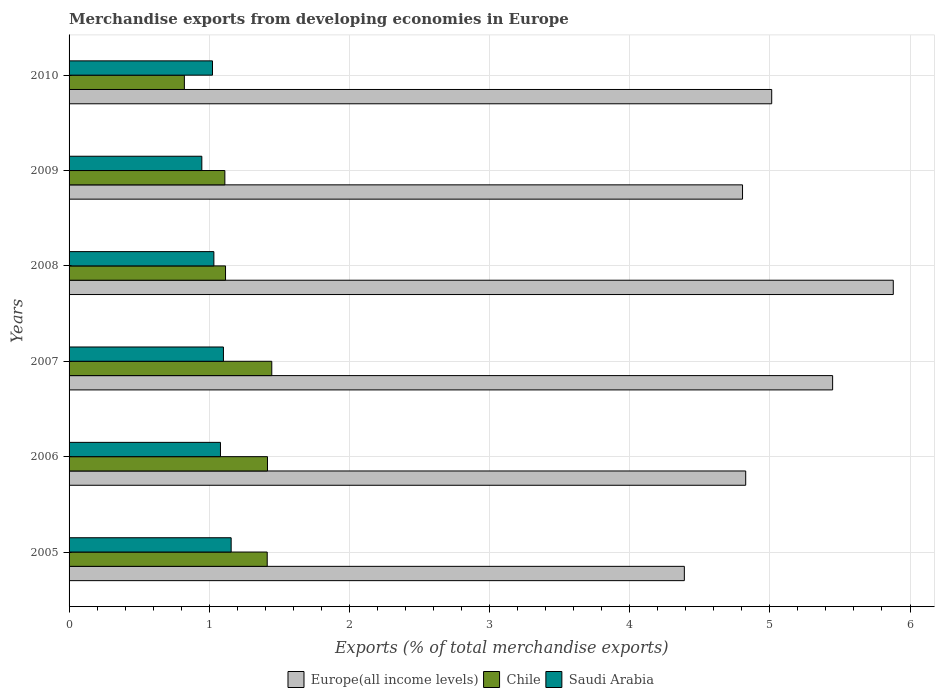Are the number of bars per tick equal to the number of legend labels?
Give a very brief answer. Yes. Are the number of bars on each tick of the Y-axis equal?
Ensure brevity in your answer.  Yes. How many bars are there on the 3rd tick from the top?
Give a very brief answer. 3. In how many cases, is the number of bars for a given year not equal to the number of legend labels?
Your response must be concise. 0. What is the percentage of total merchandise exports in Chile in 2007?
Make the answer very short. 1.45. Across all years, what is the maximum percentage of total merchandise exports in Chile?
Ensure brevity in your answer.  1.45. Across all years, what is the minimum percentage of total merchandise exports in Europe(all income levels)?
Your response must be concise. 4.39. In which year was the percentage of total merchandise exports in Europe(all income levels) maximum?
Offer a very short reply. 2008. In which year was the percentage of total merchandise exports in Saudi Arabia minimum?
Your response must be concise. 2009. What is the total percentage of total merchandise exports in Saudi Arabia in the graph?
Your answer should be compact. 6.34. What is the difference between the percentage of total merchandise exports in Saudi Arabia in 2006 and that in 2008?
Ensure brevity in your answer.  0.05. What is the difference between the percentage of total merchandise exports in Europe(all income levels) in 2009 and the percentage of total merchandise exports in Saudi Arabia in 2008?
Provide a succinct answer. 3.77. What is the average percentage of total merchandise exports in Europe(all income levels) per year?
Your response must be concise. 5.06. In the year 2010, what is the difference between the percentage of total merchandise exports in Europe(all income levels) and percentage of total merchandise exports in Saudi Arabia?
Provide a succinct answer. 3.99. What is the ratio of the percentage of total merchandise exports in Chile in 2005 to that in 2010?
Offer a very short reply. 1.72. Is the percentage of total merchandise exports in Chile in 2007 less than that in 2008?
Your answer should be compact. No. Is the difference between the percentage of total merchandise exports in Europe(all income levels) in 2005 and 2010 greater than the difference between the percentage of total merchandise exports in Saudi Arabia in 2005 and 2010?
Provide a succinct answer. No. What is the difference between the highest and the second highest percentage of total merchandise exports in Europe(all income levels)?
Your answer should be very brief. 0.43. What is the difference between the highest and the lowest percentage of total merchandise exports in Saudi Arabia?
Offer a terse response. 0.21. In how many years, is the percentage of total merchandise exports in Europe(all income levels) greater than the average percentage of total merchandise exports in Europe(all income levels) taken over all years?
Keep it short and to the point. 2. What does the 3rd bar from the top in 2007 represents?
Provide a short and direct response. Europe(all income levels). What does the 3rd bar from the bottom in 2008 represents?
Your answer should be very brief. Saudi Arabia. Is it the case that in every year, the sum of the percentage of total merchandise exports in Europe(all income levels) and percentage of total merchandise exports in Chile is greater than the percentage of total merchandise exports in Saudi Arabia?
Offer a very short reply. Yes. How many bars are there?
Your answer should be compact. 18. Are all the bars in the graph horizontal?
Provide a succinct answer. Yes. How many years are there in the graph?
Give a very brief answer. 6. What is the difference between two consecutive major ticks on the X-axis?
Your answer should be compact. 1. Are the values on the major ticks of X-axis written in scientific E-notation?
Your answer should be very brief. No. How many legend labels are there?
Make the answer very short. 3. How are the legend labels stacked?
Your answer should be very brief. Horizontal. What is the title of the graph?
Offer a terse response. Merchandise exports from developing economies in Europe. Does "Mauritius" appear as one of the legend labels in the graph?
Your answer should be compact. No. What is the label or title of the X-axis?
Your answer should be very brief. Exports (% of total merchandise exports). What is the label or title of the Y-axis?
Your answer should be very brief. Years. What is the Exports (% of total merchandise exports) of Europe(all income levels) in 2005?
Make the answer very short. 4.39. What is the Exports (% of total merchandise exports) of Chile in 2005?
Make the answer very short. 1.41. What is the Exports (% of total merchandise exports) of Saudi Arabia in 2005?
Ensure brevity in your answer.  1.16. What is the Exports (% of total merchandise exports) of Europe(all income levels) in 2006?
Your answer should be very brief. 4.83. What is the Exports (% of total merchandise exports) of Chile in 2006?
Make the answer very short. 1.42. What is the Exports (% of total merchandise exports) in Saudi Arabia in 2006?
Your response must be concise. 1.08. What is the Exports (% of total merchandise exports) of Europe(all income levels) in 2007?
Give a very brief answer. 5.45. What is the Exports (% of total merchandise exports) in Chile in 2007?
Give a very brief answer. 1.45. What is the Exports (% of total merchandise exports) of Saudi Arabia in 2007?
Offer a terse response. 1.1. What is the Exports (% of total merchandise exports) in Europe(all income levels) in 2008?
Provide a short and direct response. 5.88. What is the Exports (% of total merchandise exports) of Chile in 2008?
Offer a terse response. 1.12. What is the Exports (% of total merchandise exports) of Saudi Arabia in 2008?
Provide a short and direct response. 1.03. What is the Exports (% of total merchandise exports) of Europe(all income levels) in 2009?
Offer a very short reply. 4.81. What is the Exports (% of total merchandise exports) of Chile in 2009?
Give a very brief answer. 1.11. What is the Exports (% of total merchandise exports) of Saudi Arabia in 2009?
Offer a terse response. 0.95. What is the Exports (% of total merchandise exports) in Europe(all income levels) in 2010?
Keep it short and to the point. 5.01. What is the Exports (% of total merchandise exports) of Chile in 2010?
Your response must be concise. 0.82. What is the Exports (% of total merchandise exports) of Saudi Arabia in 2010?
Your answer should be very brief. 1.02. Across all years, what is the maximum Exports (% of total merchandise exports) of Europe(all income levels)?
Keep it short and to the point. 5.88. Across all years, what is the maximum Exports (% of total merchandise exports) of Chile?
Ensure brevity in your answer.  1.45. Across all years, what is the maximum Exports (% of total merchandise exports) of Saudi Arabia?
Keep it short and to the point. 1.16. Across all years, what is the minimum Exports (% of total merchandise exports) of Europe(all income levels)?
Give a very brief answer. 4.39. Across all years, what is the minimum Exports (% of total merchandise exports) of Chile?
Provide a succinct answer. 0.82. Across all years, what is the minimum Exports (% of total merchandise exports) in Saudi Arabia?
Your answer should be very brief. 0.95. What is the total Exports (% of total merchandise exports) of Europe(all income levels) in the graph?
Your answer should be compact. 30.36. What is the total Exports (% of total merchandise exports) of Chile in the graph?
Offer a terse response. 7.33. What is the total Exports (% of total merchandise exports) of Saudi Arabia in the graph?
Your answer should be compact. 6.34. What is the difference between the Exports (% of total merchandise exports) of Europe(all income levels) in 2005 and that in 2006?
Make the answer very short. -0.44. What is the difference between the Exports (% of total merchandise exports) of Chile in 2005 and that in 2006?
Ensure brevity in your answer.  -0. What is the difference between the Exports (% of total merchandise exports) in Saudi Arabia in 2005 and that in 2006?
Your answer should be very brief. 0.08. What is the difference between the Exports (% of total merchandise exports) of Europe(all income levels) in 2005 and that in 2007?
Keep it short and to the point. -1.06. What is the difference between the Exports (% of total merchandise exports) in Chile in 2005 and that in 2007?
Keep it short and to the point. -0.03. What is the difference between the Exports (% of total merchandise exports) in Saudi Arabia in 2005 and that in 2007?
Ensure brevity in your answer.  0.06. What is the difference between the Exports (% of total merchandise exports) in Europe(all income levels) in 2005 and that in 2008?
Your answer should be compact. -1.49. What is the difference between the Exports (% of total merchandise exports) in Chile in 2005 and that in 2008?
Ensure brevity in your answer.  0.3. What is the difference between the Exports (% of total merchandise exports) of Saudi Arabia in 2005 and that in 2008?
Provide a short and direct response. 0.12. What is the difference between the Exports (% of total merchandise exports) in Europe(all income levels) in 2005 and that in 2009?
Offer a terse response. -0.42. What is the difference between the Exports (% of total merchandise exports) in Chile in 2005 and that in 2009?
Your response must be concise. 0.3. What is the difference between the Exports (% of total merchandise exports) in Saudi Arabia in 2005 and that in 2009?
Make the answer very short. 0.21. What is the difference between the Exports (% of total merchandise exports) in Europe(all income levels) in 2005 and that in 2010?
Your response must be concise. -0.62. What is the difference between the Exports (% of total merchandise exports) in Chile in 2005 and that in 2010?
Ensure brevity in your answer.  0.59. What is the difference between the Exports (% of total merchandise exports) of Saudi Arabia in 2005 and that in 2010?
Make the answer very short. 0.13. What is the difference between the Exports (% of total merchandise exports) of Europe(all income levels) in 2006 and that in 2007?
Your answer should be very brief. -0.62. What is the difference between the Exports (% of total merchandise exports) in Chile in 2006 and that in 2007?
Offer a very short reply. -0.03. What is the difference between the Exports (% of total merchandise exports) in Saudi Arabia in 2006 and that in 2007?
Offer a terse response. -0.02. What is the difference between the Exports (% of total merchandise exports) of Europe(all income levels) in 2006 and that in 2008?
Offer a very short reply. -1.05. What is the difference between the Exports (% of total merchandise exports) in Chile in 2006 and that in 2008?
Provide a short and direct response. 0.3. What is the difference between the Exports (% of total merchandise exports) in Saudi Arabia in 2006 and that in 2008?
Offer a very short reply. 0.05. What is the difference between the Exports (% of total merchandise exports) of Europe(all income levels) in 2006 and that in 2009?
Make the answer very short. 0.02. What is the difference between the Exports (% of total merchandise exports) of Chile in 2006 and that in 2009?
Your response must be concise. 0.3. What is the difference between the Exports (% of total merchandise exports) of Saudi Arabia in 2006 and that in 2009?
Give a very brief answer. 0.13. What is the difference between the Exports (% of total merchandise exports) of Europe(all income levels) in 2006 and that in 2010?
Your answer should be compact. -0.19. What is the difference between the Exports (% of total merchandise exports) of Chile in 2006 and that in 2010?
Your response must be concise. 0.59. What is the difference between the Exports (% of total merchandise exports) of Saudi Arabia in 2006 and that in 2010?
Offer a very short reply. 0.06. What is the difference between the Exports (% of total merchandise exports) in Europe(all income levels) in 2007 and that in 2008?
Offer a terse response. -0.43. What is the difference between the Exports (% of total merchandise exports) in Chile in 2007 and that in 2008?
Give a very brief answer. 0.33. What is the difference between the Exports (% of total merchandise exports) of Saudi Arabia in 2007 and that in 2008?
Keep it short and to the point. 0.07. What is the difference between the Exports (% of total merchandise exports) of Europe(all income levels) in 2007 and that in 2009?
Keep it short and to the point. 0.64. What is the difference between the Exports (% of total merchandise exports) of Chile in 2007 and that in 2009?
Offer a terse response. 0.33. What is the difference between the Exports (% of total merchandise exports) of Saudi Arabia in 2007 and that in 2009?
Provide a succinct answer. 0.15. What is the difference between the Exports (% of total merchandise exports) in Europe(all income levels) in 2007 and that in 2010?
Provide a succinct answer. 0.43. What is the difference between the Exports (% of total merchandise exports) of Chile in 2007 and that in 2010?
Keep it short and to the point. 0.62. What is the difference between the Exports (% of total merchandise exports) of Saudi Arabia in 2007 and that in 2010?
Ensure brevity in your answer.  0.08. What is the difference between the Exports (% of total merchandise exports) in Europe(all income levels) in 2008 and that in 2009?
Offer a terse response. 1.08. What is the difference between the Exports (% of total merchandise exports) in Chile in 2008 and that in 2009?
Give a very brief answer. 0. What is the difference between the Exports (% of total merchandise exports) of Saudi Arabia in 2008 and that in 2009?
Your answer should be compact. 0.09. What is the difference between the Exports (% of total merchandise exports) in Europe(all income levels) in 2008 and that in 2010?
Give a very brief answer. 0.87. What is the difference between the Exports (% of total merchandise exports) in Chile in 2008 and that in 2010?
Offer a terse response. 0.29. What is the difference between the Exports (% of total merchandise exports) in Saudi Arabia in 2008 and that in 2010?
Your answer should be compact. 0.01. What is the difference between the Exports (% of total merchandise exports) of Europe(all income levels) in 2009 and that in 2010?
Your answer should be very brief. -0.21. What is the difference between the Exports (% of total merchandise exports) in Chile in 2009 and that in 2010?
Give a very brief answer. 0.29. What is the difference between the Exports (% of total merchandise exports) in Saudi Arabia in 2009 and that in 2010?
Your answer should be very brief. -0.08. What is the difference between the Exports (% of total merchandise exports) of Europe(all income levels) in 2005 and the Exports (% of total merchandise exports) of Chile in 2006?
Give a very brief answer. 2.97. What is the difference between the Exports (% of total merchandise exports) in Europe(all income levels) in 2005 and the Exports (% of total merchandise exports) in Saudi Arabia in 2006?
Your response must be concise. 3.31. What is the difference between the Exports (% of total merchandise exports) in Chile in 2005 and the Exports (% of total merchandise exports) in Saudi Arabia in 2006?
Offer a terse response. 0.33. What is the difference between the Exports (% of total merchandise exports) of Europe(all income levels) in 2005 and the Exports (% of total merchandise exports) of Chile in 2007?
Offer a terse response. 2.94. What is the difference between the Exports (% of total merchandise exports) of Europe(all income levels) in 2005 and the Exports (% of total merchandise exports) of Saudi Arabia in 2007?
Offer a very short reply. 3.29. What is the difference between the Exports (% of total merchandise exports) in Chile in 2005 and the Exports (% of total merchandise exports) in Saudi Arabia in 2007?
Provide a succinct answer. 0.31. What is the difference between the Exports (% of total merchandise exports) of Europe(all income levels) in 2005 and the Exports (% of total merchandise exports) of Chile in 2008?
Offer a terse response. 3.27. What is the difference between the Exports (% of total merchandise exports) in Europe(all income levels) in 2005 and the Exports (% of total merchandise exports) in Saudi Arabia in 2008?
Your response must be concise. 3.36. What is the difference between the Exports (% of total merchandise exports) in Chile in 2005 and the Exports (% of total merchandise exports) in Saudi Arabia in 2008?
Your answer should be very brief. 0.38. What is the difference between the Exports (% of total merchandise exports) of Europe(all income levels) in 2005 and the Exports (% of total merchandise exports) of Chile in 2009?
Your response must be concise. 3.28. What is the difference between the Exports (% of total merchandise exports) of Europe(all income levels) in 2005 and the Exports (% of total merchandise exports) of Saudi Arabia in 2009?
Ensure brevity in your answer.  3.44. What is the difference between the Exports (% of total merchandise exports) of Chile in 2005 and the Exports (% of total merchandise exports) of Saudi Arabia in 2009?
Give a very brief answer. 0.47. What is the difference between the Exports (% of total merchandise exports) in Europe(all income levels) in 2005 and the Exports (% of total merchandise exports) in Chile in 2010?
Offer a terse response. 3.57. What is the difference between the Exports (% of total merchandise exports) in Europe(all income levels) in 2005 and the Exports (% of total merchandise exports) in Saudi Arabia in 2010?
Keep it short and to the point. 3.37. What is the difference between the Exports (% of total merchandise exports) in Chile in 2005 and the Exports (% of total merchandise exports) in Saudi Arabia in 2010?
Ensure brevity in your answer.  0.39. What is the difference between the Exports (% of total merchandise exports) of Europe(all income levels) in 2006 and the Exports (% of total merchandise exports) of Chile in 2007?
Offer a very short reply. 3.38. What is the difference between the Exports (% of total merchandise exports) of Europe(all income levels) in 2006 and the Exports (% of total merchandise exports) of Saudi Arabia in 2007?
Offer a very short reply. 3.73. What is the difference between the Exports (% of total merchandise exports) in Chile in 2006 and the Exports (% of total merchandise exports) in Saudi Arabia in 2007?
Give a very brief answer. 0.31. What is the difference between the Exports (% of total merchandise exports) in Europe(all income levels) in 2006 and the Exports (% of total merchandise exports) in Chile in 2008?
Provide a succinct answer. 3.71. What is the difference between the Exports (% of total merchandise exports) in Europe(all income levels) in 2006 and the Exports (% of total merchandise exports) in Saudi Arabia in 2008?
Give a very brief answer. 3.79. What is the difference between the Exports (% of total merchandise exports) of Chile in 2006 and the Exports (% of total merchandise exports) of Saudi Arabia in 2008?
Your answer should be very brief. 0.38. What is the difference between the Exports (% of total merchandise exports) in Europe(all income levels) in 2006 and the Exports (% of total merchandise exports) in Chile in 2009?
Provide a succinct answer. 3.72. What is the difference between the Exports (% of total merchandise exports) in Europe(all income levels) in 2006 and the Exports (% of total merchandise exports) in Saudi Arabia in 2009?
Offer a terse response. 3.88. What is the difference between the Exports (% of total merchandise exports) of Chile in 2006 and the Exports (% of total merchandise exports) of Saudi Arabia in 2009?
Provide a short and direct response. 0.47. What is the difference between the Exports (% of total merchandise exports) of Europe(all income levels) in 2006 and the Exports (% of total merchandise exports) of Chile in 2010?
Keep it short and to the point. 4. What is the difference between the Exports (% of total merchandise exports) of Europe(all income levels) in 2006 and the Exports (% of total merchandise exports) of Saudi Arabia in 2010?
Your answer should be compact. 3.8. What is the difference between the Exports (% of total merchandise exports) of Chile in 2006 and the Exports (% of total merchandise exports) of Saudi Arabia in 2010?
Your answer should be very brief. 0.39. What is the difference between the Exports (% of total merchandise exports) in Europe(all income levels) in 2007 and the Exports (% of total merchandise exports) in Chile in 2008?
Offer a terse response. 4.33. What is the difference between the Exports (% of total merchandise exports) of Europe(all income levels) in 2007 and the Exports (% of total merchandise exports) of Saudi Arabia in 2008?
Give a very brief answer. 4.41. What is the difference between the Exports (% of total merchandise exports) in Chile in 2007 and the Exports (% of total merchandise exports) in Saudi Arabia in 2008?
Provide a succinct answer. 0.41. What is the difference between the Exports (% of total merchandise exports) in Europe(all income levels) in 2007 and the Exports (% of total merchandise exports) in Chile in 2009?
Offer a very short reply. 4.34. What is the difference between the Exports (% of total merchandise exports) of Europe(all income levels) in 2007 and the Exports (% of total merchandise exports) of Saudi Arabia in 2009?
Offer a very short reply. 4.5. What is the difference between the Exports (% of total merchandise exports) of Chile in 2007 and the Exports (% of total merchandise exports) of Saudi Arabia in 2009?
Your answer should be compact. 0.5. What is the difference between the Exports (% of total merchandise exports) of Europe(all income levels) in 2007 and the Exports (% of total merchandise exports) of Chile in 2010?
Provide a short and direct response. 4.63. What is the difference between the Exports (% of total merchandise exports) in Europe(all income levels) in 2007 and the Exports (% of total merchandise exports) in Saudi Arabia in 2010?
Offer a terse response. 4.42. What is the difference between the Exports (% of total merchandise exports) of Chile in 2007 and the Exports (% of total merchandise exports) of Saudi Arabia in 2010?
Provide a short and direct response. 0.42. What is the difference between the Exports (% of total merchandise exports) of Europe(all income levels) in 2008 and the Exports (% of total merchandise exports) of Chile in 2009?
Offer a terse response. 4.77. What is the difference between the Exports (% of total merchandise exports) in Europe(all income levels) in 2008 and the Exports (% of total merchandise exports) in Saudi Arabia in 2009?
Offer a terse response. 4.93. What is the difference between the Exports (% of total merchandise exports) of Chile in 2008 and the Exports (% of total merchandise exports) of Saudi Arabia in 2009?
Ensure brevity in your answer.  0.17. What is the difference between the Exports (% of total merchandise exports) in Europe(all income levels) in 2008 and the Exports (% of total merchandise exports) in Chile in 2010?
Provide a short and direct response. 5.06. What is the difference between the Exports (% of total merchandise exports) in Europe(all income levels) in 2008 and the Exports (% of total merchandise exports) in Saudi Arabia in 2010?
Offer a very short reply. 4.86. What is the difference between the Exports (% of total merchandise exports) in Chile in 2008 and the Exports (% of total merchandise exports) in Saudi Arabia in 2010?
Ensure brevity in your answer.  0.09. What is the difference between the Exports (% of total merchandise exports) in Europe(all income levels) in 2009 and the Exports (% of total merchandise exports) in Chile in 2010?
Provide a succinct answer. 3.98. What is the difference between the Exports (% of total merchandise exports) of Europe(all income levels) in 2009 and the Exports (% of total merchandise exports) of Saudi Arabia in 2010?
Keep it short and to the point. 3.78. What is the difference between the Exports (% of total merchandise exports) of Chile in 2009 and the Exports (% of total merchandise exports) of Saudi Arabia in 2010?
Provide a short and direct response. 0.09. What is the average Exports (% of total merchandise exports) of Europe(all income levels) per year?
Provide a succinct answer. 5.06. What is the average Exports (% of total merchandise exports) of Chile per year?
Make the answer very short. 1.22. What is the average Exports (% of total merchandise exports) in Saudi Arabia per year?
Your answer should be compact. 1.06. In the year 2005, what is the difference between the Exports (% of total merchandise exports) of Europe(all income levels) and Exports (% of total merchandise exports) of Chile?
Provide a succinct answer. 2.98. In the year 2005, what is the difference between the Exports (% of total merchandise exports) in Europe(all income levels) and Exports (% of total merchandise exports) in Saudi Arabia?
Ensure brevity in your answer.  3.23. In the year 2005, what is the difference between the Exports (% of total merchandise exports) in Chile and Exports (% of total merchandise exports) in Saudi Arabia?
Offer a very short reply. 0.26. In the year 2006, what is the difference between the Exports (% of total merchandise exports) in Europe(all income levels) and Exports (% of total merchandise exports) in Chile?
Your response must be concise. 3.41. In the year 2006, what is the difference between the Exports (% of total merchandise exports) of Europe(all income levels) and Exports (% of total merchandise exports) of Saudi Arabia?
Your response must be concise. 3.75. In the year 2006, what is the difference between the Exports (% of total merchandise exports) in Chile and Exports (% of total merchandise exports) in Saudi Arabia?
Provide a succinct answer. 0.34. In the year 2007, what is the difference between the Exports (% of total merchandise exports) of Europe(all income levels) and Exports (% of total merchandise exports) of Chile?
Provide a short and direct response. 4. In the year 2007, what is the difference between the Exports (% of total merchandise exports) in Europe(all income levels) and Exports (% of total merchandise exports) in Saudi Arabia?
Ensure brevity in your answer.  4.35. In the year 2007, what is the difference between the Exports (% of total merchandise exports) in Chile and Exports (% of total merchandise exports) in Saudi Arabia?
Your response must be concise. 0.34. In the year 2008, what is the difference between the Exports (% of total merchandise exports) in Europe(all income levels) and Exports (% of total merchandise exports) in Chile?
Offer a very short reply. 4.76. In the year 2008, what is the difference between the Exports (% of total merchandise exports) in Europe(all income levels) and Exports (% of total merchandise exports) in Saudi Arabia?
Your response must be concise. 4.85. In the year 2008, what is the difference between the Exports (% of total merchandise exports) of Chile and Exports (% of total merchandise exports) of Saudi Arabia?
Provide a short and direct response. 0.08. In the year 2009, what is the difference between the Exports (% of total merchandise exports) of Europe(all income levels) and Exports (% of total merchandise exports) of Chile?
Your answer should be very brief. 3.69. In the year 2009, what is the difference between the Exports (% of total merchandise exports) in Europe(all income levels) and Exports (% of total merchandise exports) in Saudi Arabia?
Your response must be concise. 3.86. In the year 2009, what is the difference between the Exports (% of total merchandise exports) in Chile and Exports (% of total merchandise exports) in Saudi Arabia?
Your answer should be very brief. 0.16. In the year 2010, what is the difference between the Exports (% of total merchandise exports) of Europe(all income levels) and Exports (% of total merchandise exports) of Chile?
Offer a terse response. 4.19. In the year 2010, what is the difference between the Exports (% of total merchandise exports) of Europe(all income levels) and Exports (% of total merchandise exports) of Saudi Arabia?
Ensure brevity in your answer.  3.99. In the year 2010, what is the difference between the Exports (% of total merchandise exports) of Chile and Exports (% of total merchandise exports) of Saudi Arabia?
Offer a terse response. -0.2. What is the ratio of the Exports (% of total merchandise exports) in Europe(all income levels) in 2005 to that in 2006?
Make the answer very short. 0.91. What is the ratio of the Exports (% of total merchandise exports) of Chile in 2005 to that in 2006?
Make the answer very short. 1. What is the ratio of the Exports (% of total merchandise exports) in Saudi Arabia in 2005 to that in 2006?
Offer a very short reply. 1.07. What is the ratio of the Exports (% of total merchandise exports) in Europe(all income levels) in 2005 to that in 2007?
Offer a very short reply. 0.81. What is the ratio of the Exports (% of total merchandise exports) in Chile in 2005 to that in 2007?
Make the answer very short. 0.98. What is the ratio of the Exports (% of total merchandise exports) of Saudi Arabia in 2005 to that in 2007?
Offer a terse response. 1.05. What is the ratio of the Exports (% of total merchandise exports) in Europe(all income levels) in 2005 to that in 2008?
Give a very brief answer. 0.75. What is the ratio of the Exports (% of total merchandise exports) in Chile in 2005 to that in 2008?
Your response must be concise. 1.27. What is the ratio of the Exports (% of total merchandise exports) of Saudi Arabia in 2005 to that in 2008?
Provide a short and direct response. 1.12. What is the ratio of the Exports (% of total merchandise exports) of Europe(all income levels) in 2005 to that in 2009?
Offer a very short reply. 0.91. What is the ratio of the Exports (% of total merchandise exports) of Chile in 2005 to that in 2009?
Offer a very short reply. 1.27. What is the ratio of the Exports (% of total merchandise exports) in Saudi Arabia in 2005 to that in 2009?
Your response must be concise. 1.22. What is the ratio of the Exports (% of total merchandise exports) of Europe(all income levels) in 2005 to that in 2010?
Ensure brevity in your answer.  0.88. What is the ratio of the Exports (% of total merchandise exports) in Chile in 2005 to that in 2010?
Give a very brief answer. 1.72. What is the ratio of the Exports (% of total merchandise exports) in Saudi Arabia in 2005 to that in 2010?
Offer a very short reply. 1.13. What is the ratio of the Exports (% of total merchandise exports) in Europe(all income levels) in 2006 to that in 2007?
Your answer should be compact. 0.89. What is the ratio of the Exports (% of total merchandise exports) in Chile in 2006 to that in 2007?
Give a very brief answer. 0.98. What is the ratio of the Exports (% of total merchandise exports) of Saudi Arabia in 2006 to that in 2007?
Offer a terse response. 0.98. What is the ratio of the Exports (% of total merchandise exports) in Europe(all income levels) in 2006 to that in 2008?
Ensure brevity in your answer.  0.82. What is the ratio of the Exports (% of total merchandise exports) in Chile in 2006 to that in 2008?
Ensure brevity in your answer.  1.27. What is the ratio of the Exports (% of total merchandise exports) in Saudi Arabia in 2006 to that in 2008?
Keep it short and to the point. 1.05. What is the ratio of the Exports (% of total merchandise exports) in Europe(all income levels) in 2006 to that in 2009?
Your answer should be very brief. 1. What is the ratio of the Exports (% of total merchandise exports) in Chile in 2006 to that in 2009?
Give a very brief answer. 1.27. What is the ratio of the Exports (% of total merchandise exports) in Saudi Arabia in 2006 to that in 2009?
Your answer should be compact. 1.14. What is the ratio of the Exports (% of total merchandise exports) of Europe(all income levels) in 2006 to that in 2010?
Offer a terse response. 0.96. What is the ratio of the Exports (% of total merchandise exports) in Chile in 2006 to that in 2010?
Provide a succinct answer. 1.72. What is the ratio of the Exports (% of total merchandise exports) of Saudi Arabia in 2006 to that in 2010?
Provide a short and direct response. 1.06. What is the ratio of the Exports (% of total merchandise exports) in Europe(all income levels) in 2007 to that in 2008?
Offer a very short reply. 0.93. What is the ratio of the Exports (% of total merchandise exports) of Chile in 2007 to that in 2008?
Give a very brief answer. 1.3. What is the ratio of the Exports (% of total merchandise exports) in Saudi Arabia in 2007 to that in 2008?
Keep it short and to the point. 1.07. What is the ratio of the Exports (% of total merchandise exports) of Europe(all income levels) in 2007 to that in 2009?
Ensure brevity in your answer.  1.13. What is the ratio of the Exports (% of total merchandise exports) of Chile in 2007 to that in 2009?
Your answer should be very brief. 1.3. What is the ratio of the Exports (% of total merchandise exports) in Saudi Arabia in 2007 to that in 2009?
Your answer should be very brief. 1.16. What is the ratio of the Exports (% of total merchandise exports) of Europe(all income levels) in 2007 to that in 2010?
Offer a very short reply. 1.09. What is the ratio of the Exports (% of total merchandise exports) in Chile in 2007 to that in 2010?
Give a very brief answer. 1.76. What is the ratio of the Exports (% of total merchandise exports) of Saudi Arabia in 2007 to that in 2010?
Make the answer very short. 1.08. What is the ratio of the Exports (% of total merchandise exports) in Europe(all income levels) in 2008 to that in 2009?
Give a very brief answer. 1.22. What is the ratio of the Exports (% of total merchandise exports) of Chile in 2008 to that in 2009?
Your answer should be compact. 1. What is the ratio of the Exports (% of total merchandise exports) in Saudi Arabia in 2008 to that in 2009?
Give a very brief answer. 1.09. What is the ratio of the Exports (% of total merchandise exports) of Europe(all income levels) in 2008 to that in 2010?
Offer a very short reply. 1.17. What is the ratio of the Exports (% of total merchandise exports) of Chile in 2008 to that in 2010?
Offer a terse response. 1.36. What is the ratio of the Exports (% of total merchandise exports) in Saudi Arabia in 2008 to that in 2010?
Provide a short and direct response. 1.01. What is the ratio of the Exports (% of total merchandise exports) in Europe(all income levels) in 2009 to that in 2010?
Make the answer very short. 0.96. What is the ratio of the Exports (% of total merchandise exports) of Chile in 2009 to that in 2010?
Make the answer very short. 1.35. What is the ratio of the Exports (% of total merchandise exports) in Saudi Arabia in 2009 to that in 2010?
Give a very brief answer. 0.93. What is the difference between the highest and the second highest Exports (% of total merchandise exports) in Europe(all income levels)?
Offer a terse response. 0.43. What is the difference between the highest and the second highest Exports (% of total merchandise exports) of Chile?
Your answer should be compact. 0.03. What is the difference between the highest and the second highest Exports (% of total merchandise exports) of Saudi Arabia?
Give a very brief answer. 0.06. What is the difference between the highest and the lowest Exports (% of total merchandise exports) in Europe(all income levels)?
Your response must be concise. 1.49. What is the difference between the highest and the lowest Exports (% of total merchandise exports) of Chile?
Provide a short and direct response. 0.62. What is the difference between the highest and the lowest Exports (% of total merchandise exports) in Saudi Arabia?
Your response must be concise. 0.21. 